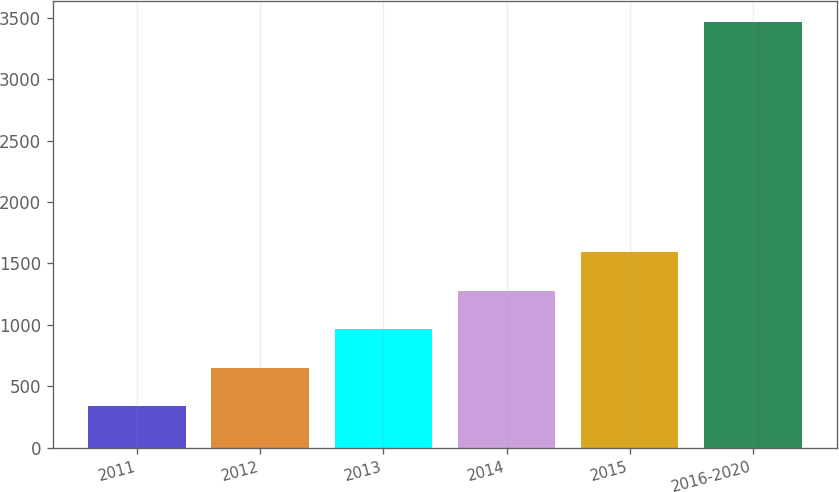<chart> <loc_0><loc_0><loc_500><loc_500><bar_chart><fcel>2011<fcel>2012<fcel>2013<fcel>2014<fcel>2015<fcel>2016-2020<nl><fcel>338<fcel>650.8<fcel>963.6<fcel>1276.4<fcel>1589.2<fcel>3466<nl></chart> 